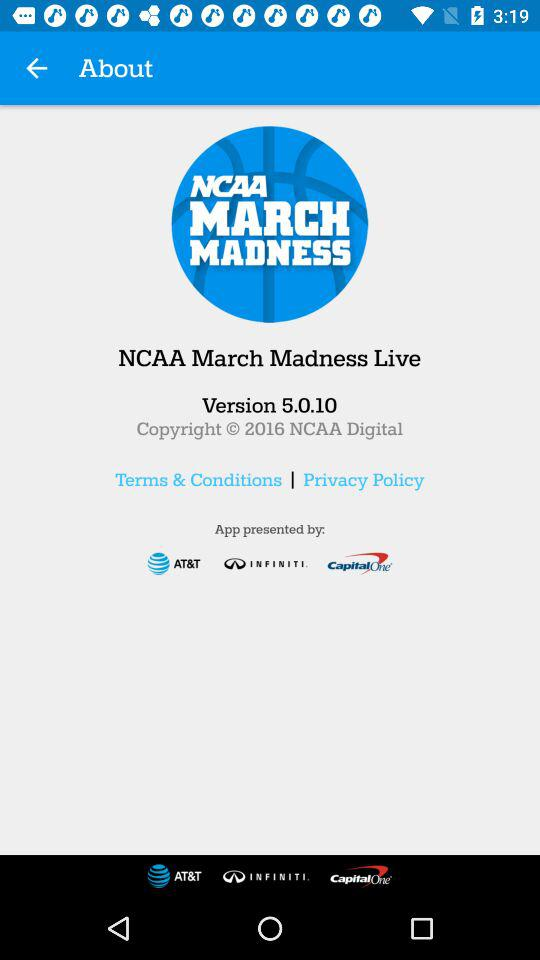What is the name of the application? The name of the application is "NCAA March Madness Live". 